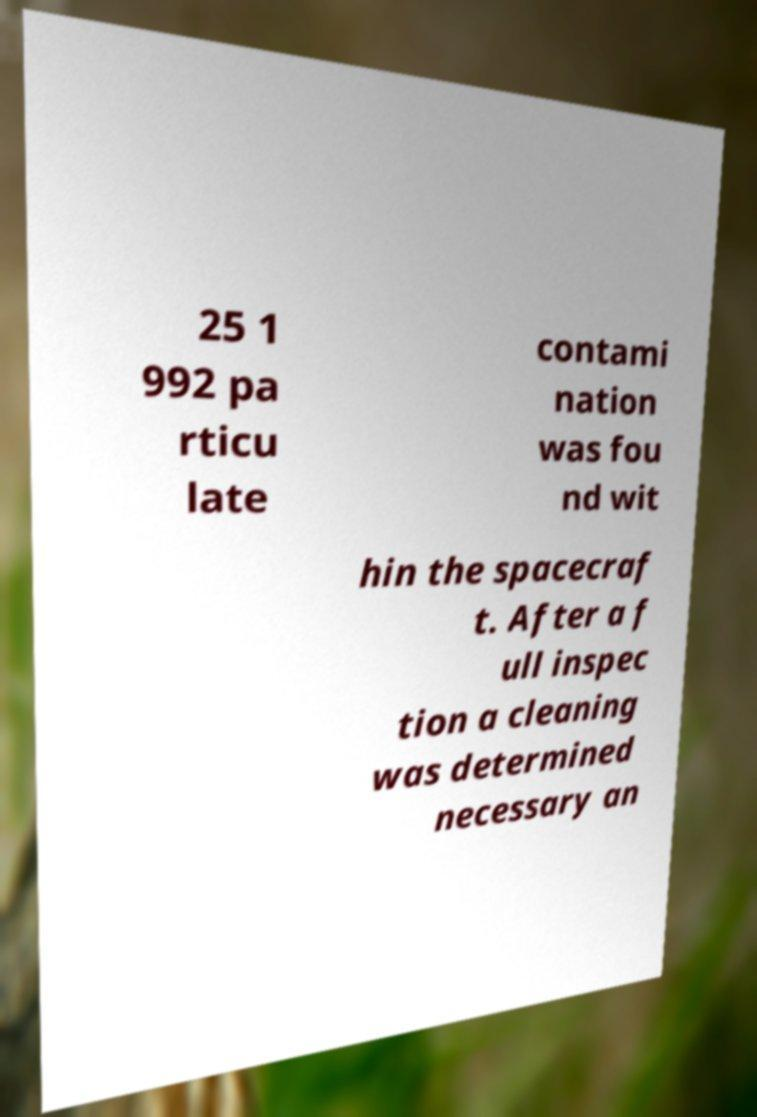Could you assist in decoding the text presented in this image and type it out clearly? 25 1 992 pa rticu late contami nation was fou nd wit hin the spacecraf t. After a f ull inspec tion a cleaning was determined necessary an 